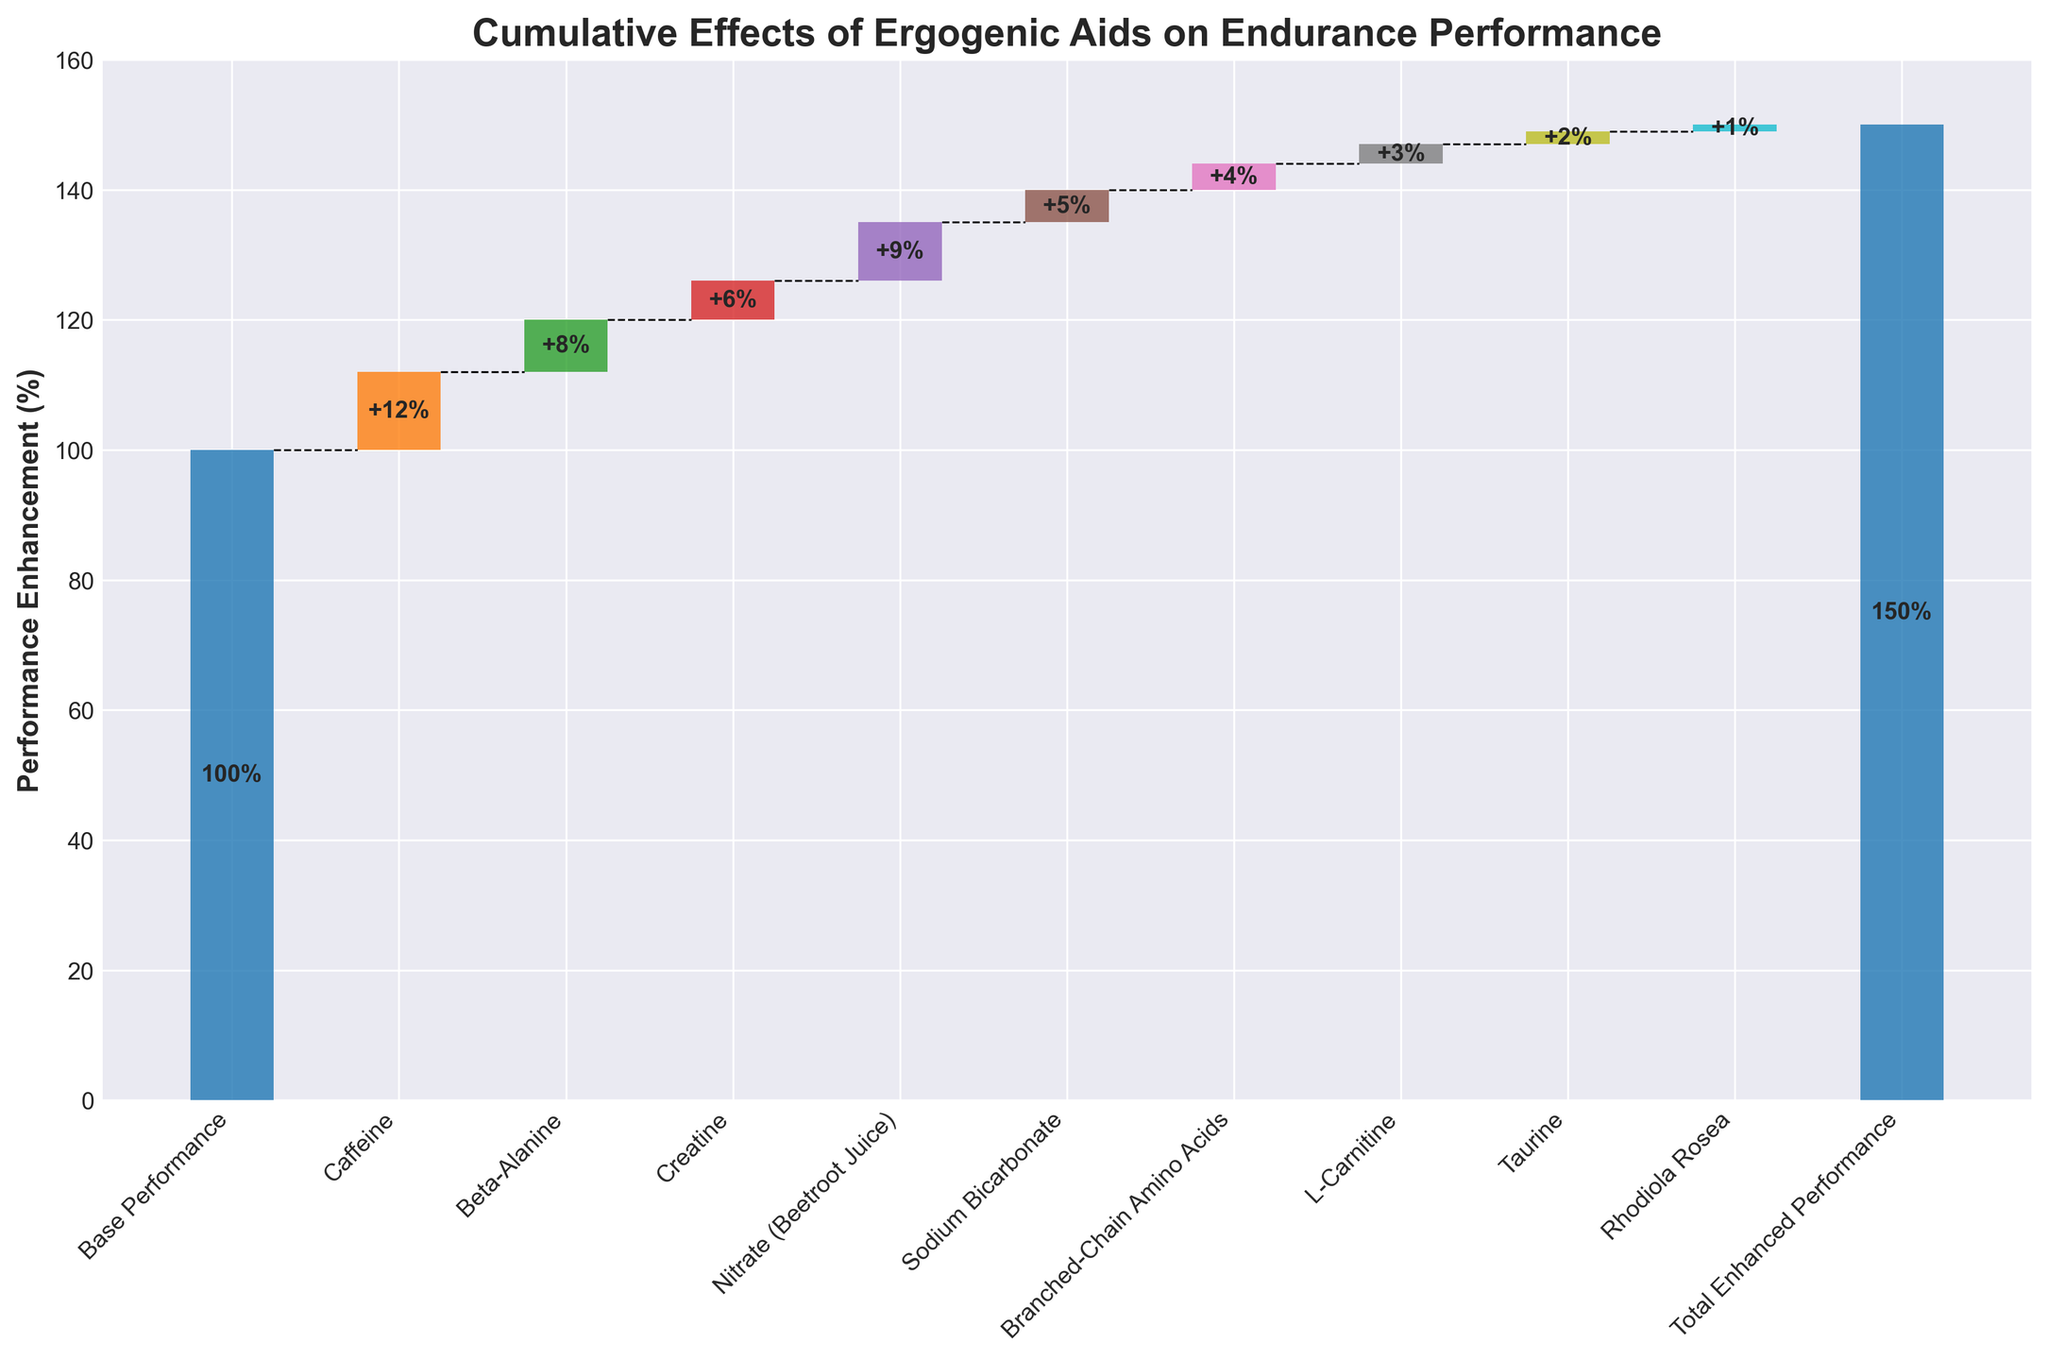Which ergogenic aid contributes the most to performance enhancement? The ergogenic aid with the highest positive contribution is Caffeine, which adds 12% enhancement to performance.
Answer: Caffeine What is the total performance enhancement provided by Beta-Alanine and Creatine together? Beta-Alanine adds 8% and Creatine adds 6%. Summing these, the total is 8% + 6% = 14%.
Answer: 14% Which supplement has the smallest performance enhancement contribution? Rhodiola Rosea adds the least performance enhancement, contributing only 1%.
Answer: Rhodiola Rosea Does the cumulative performance enhancement exceed the base performance level of 100%? Yes, the cumulative performance including all supplements' contributions reaches a total enhanced performance of 150%, which is 50% above the base performance of 100%.
Answer: Yes How much more does Nitrate (Beetroot Juice) contribute to performance compared to Taurine? Nitrate (Beetroot Juice) contributes 9%, while Taurine contributes 2%. The difference is 9% - 2% = 7%.
Answer: 7% What is the total contribution to performance enhancement from L-Carnitine, Taurine, and Rhodiola Rosea combined? L-Carnitine adds 3%, Taurine adds 2%, and Rhodiola Rosea adds 1%. The combined contribution is 3% + 2% + 1% = 6%.
Answer: 6% Which supplement contributes more to performance enhancement, Sodium Bicarbonate or Branched-Chain Amino Acids? Sodium Bicarbonate contributes 5%, which is higher than Branched-Chain Amino Acids' contribution of 4%.
Answer: Sodium Bicarbonate What is the total percentage enhancement from all supplements excluding the base performance? The contributions are: Caffeine 12%, Beta-Alanine 8%, Creatine 6%, Nitrate 9%, Sodium Bicarbonate 5%, Branched-Chain Amino Acids 4%, L-Carnitine 3%, Taurine 2%, Rhodiola Rosea 1%. Summing these gives 12% + 8% + 6% + 9% + 5% + 4% + 3% + 2% + 1% = 50%.
Answer: 50% What is the cumulative performance enhancement after adding Beta-Alanine? The base performance is 100%. Adding Beta-Alanine's 8% contribution makes the cumulative performance 100% + 8% = 108%.
Answer: 108% What are the consequences of removing the contributions of Caffeine and Sodium Bicarbonate from the total performance enhancement? Caffeine contributes 12% and Sodium Bicarbonate contributes 5%. Removing these from the total performance of 150% leaves 150% - 12% - 5% = 133%.
Answer: 133% 